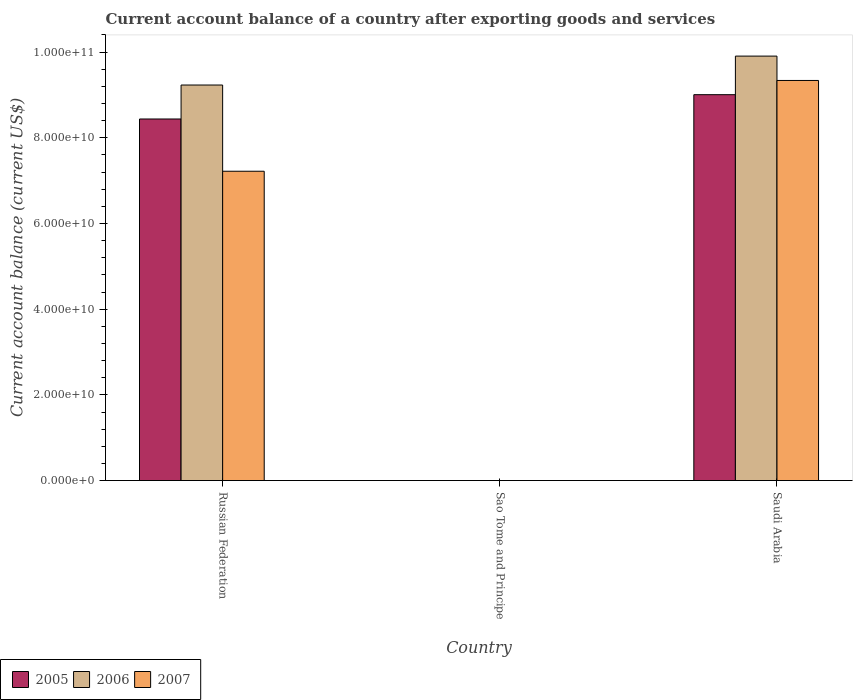How many different coloured bars are there?
Give a very brief answer. 3. How many bars are there on the 1st tick from the left?
Provide a succinct answer. 3. What is the label of the 1st group of bars from the left?
Your answer should be very brief. Russian Federation. What is the account balance in 2005 in Saudi Arabia?
Offer a terse response. 9.01e+1. Across all countries, what is the maximum account balance in 2007?
Provide a short and direct response. 9.34e+1. Across all countries, what is the minimum account balance in 2007?
Offer a terse response. 0. In which country was the account balance in 2005 maximum?
Your response must be concise. Saudi Arabia. What is the total account balance in 2005 in the graph?
Keep it short and to the point. 1.74e+11. What is the difference between the account balance in 2006 in Russian Federation and that in Saudi Arabia?
Give a very brief answer. -6.75e+09. What is the difference between the account balance in 2007 in Sao Tome and Principe and the account balance in 2005 in Saudi Arabia?
Make the answer very short. -9.01e+1. What is the average account balance in 2007 per country?
Your answer should be very brief. 5.52e+1. What is the difference between the account balance of/in 2006 and account balance of/in 2007 in Saudi Arabia?
Your answer should be compact. 5.69e+09. In how many countries, is the account balance in 2005 greater than 24000000000 US$?
Your answer should be very brief. 2. What is the ratio of the account balance in 2007 in Russian Federation to that in Saudi Arabia?
Provide a short and direct response. 0.77. Is the account balance in 2006 in Russian Federation less than that in Saudi Arabia?
Make the answer very short. Yes. Is the difference between the account balance in 2006 in Russian Federation and Saudi Arabia greater than the difference between the account balance in 2007 in Russian Federation and Saudi Arabia?
Keep it short and to the point. Yes. What is the difference between the highest and the lowest account balance in 2006?
Ensure brevity in your answer.  9.91e+1. Is it the case that in every country, the sum of the account balance in 2006 and account balance in 2005 is greater than the account balance in 2007?
Give a very brief answer. No. How many bars are there?
Make the answer very short. 6. How many countries are there in the graph?
Your answer should be compact. 3. What is the difference between two consecutive major ticks on the Y-axis?
Give a very brief answer. 2.00e+1. Does the graph contain any zero values?
Offer a very short reply. Yes. Does the graph contain grids?
Make the answer very short. No. How many legend labels are there?
Offer a very short reply. 3. What is the title of the graph?
Ensure brevity in your answer.  Current account balance of a country after exporting goods and services. Does "1976" appear as one of the legend labels in the graph?
Keep it short and to the point. No. What is the label or title of the X-axis?
Provide a succinct answer. Country. What is the label or title of the Y-axis?
Make the answer very short. Current account balance (current US$). What is the Current account balance (current US$) of 2005 in Russian Federation?
Your answer should be compact. 8.44e+1. What is the Current account balance (current US$) in 2006 in Russian Federation?
Keep it short and to the point. 9.23e+1. What is the Current account balance (current US$) in 2007 in Russian Federation?
Keep it short and to the point. 7.22e+1. What is the Current account balance (current US$) in 2005 in Saudi Arabia?
Ensure brevity in your answer.  9.01e+1. What is the Current account balance (current US$) in 2006 in Saudi Arabia?
Offer a terse response. 9.91e+1. What is the Current account balance (current US$) of 2007 in Saudi Arabia?
Your answer should be very brief. 9.34e+1. Across all countries, what is the maximum Current account balance (current US$) of 2005?
Provide a succinct answer. 9.01e+1. Across all countries, what is the maximum Current account balance (current US$) in 2006?
Your answer should be very brief. 9.91e+1. Across all countries, what is the maximum Current account balance (current US$) of 2007?
Your answer should be very brief. 9.34e+1. Across all countries, what is the minimum Current account balance (current US$) in 2006?
Provide a succinct answer. 0. What is the total Current account balance (current US$) of 2005 in the graph?
Keep it short and to the point. 1.74e+11. What is the total Current account balance (current US$) in 2006 in the graph?
Provide a succinct answer. 1.91e+11. What is the total Current account balance (current US$) of 2007 in the graph?
Your answer should be compact. 1.66e+11. What is the difference between the Current account balance (current US$) of 2005 in Russian Federation and that in Saudi Arabia?
Offer a very short reply. -5.67e+09. What is the difference between the Current account balance (current US$) of 2006 in Russian Federation and that in Saudi Arabia?
Make the answer very short. -6.75e+09. What is the difference between the Current account balance (current US$) in 2007 in Russian Federation and that in Saudi Arabia?
Your answer should be very brief. -2.12e+1. What is the difference between the Current account balance (current US$) of 2005 in Russian Federation and the Current account balance (current US$) of 2006 in Saudi Arabia?
Ensure brevity in your answer.  -1.47e+1. What is the difference between the Current account balance (current US$) in 2005 in Russian Federation and the Current account balance (current US$) in 2007 in Saudi Arabia?
Your answer should be compact. -8.99e+09. What is the difference between the Current account balance (current US$) in 2006 in Russian Federation and the Current account balance (current US$) in 2007 in Saudi Arabia?
Offer a very short reply. -1.06e+09. What is the average Current account balance (current US$) of 2005 per country?
Give a very brief answer. 5.81e+1. What is the average Current account balance (current US$) in 2006 per country?
Offer a very short reply. 6.38e+1. What is the average Current account balance (current US$) in 2007 per country?
Give a very brief answer. 5.52e+1. What is the difference between the Current account balance (current US$) of 2005 and Current account balance (current US$) of 2006 in Russian Federation?
Ensure brevity in your answer.  -7.93e+09. What is the difference between the Current account balance (current US$) of 2005 and Current account balance (current US$) of 2007 in Russian Federation?
Offer a terse response. 1.22e+1. What is the difference between the Current account balance (current US$) in 2006 and Current account balance (current US$) in 2007 in Russian Federation?
Your answer should be very brief. 2.01e+1. What is the difference between the Current account balance (current US$) of 2005 and Current account balance (current US$) of 2006 in Saudi Arabia?
Provide a succinct answer. -9.01e+09. What is the difference between the Current account balance (current US$) of 2005 and Current account balance (current US$) of 2007 in Saudi Arabia?
Provide a succinct answer. -3.32e+09. What is the difference between the Current account balance (current US$) of 2006 and Current account balance (current US$) of 2007 in Saudi Arabia?
Offer a very short reply. 5.69e+09. What is the ratio of the Current account balance (current US$) in 2005 in Russian Federation to that in Saudi Arabia?
Keep it short and to the point. 0.94. What is the ratio of the Current account balance (current US$) of 2006 in Russian Federation to that in Saudi Arabia?
Provide a succinct answer. 0.93. What is the ratio of the Current account balance (current US$) of 2007 in Russian Federation to that in Saudi Arabia?
Offer a very short reply. 0.77. What is the difference between the highest and the lowest Current account balance (current US$) in 2005?
Your response must be concise. 9.01e+1. What is the difference between the highest and the lowest Current account balance (current US$) of 2006?
Keep it short and to the point. 9.91e+1. What is the difference between the highest and the lowest Current account balance (current US$) of 2007?
Ensure brevity in your answer.  9.34e+1. 